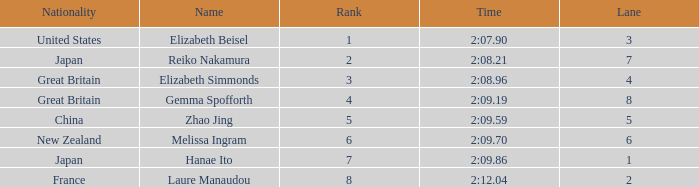What is Elizabeth Simmonds' average lane number? 4.0. 